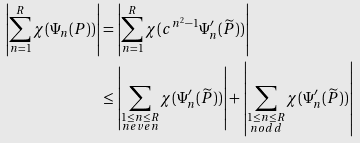<formula> <loc_0><loc_0><loc_500><loc_500>\left | \sum _ { n = 1 } ^ { R } \chi ( \Psi _ { n } ( P ) ) \right | & = \left | \sum _ { n = 1 } ^ { R } \chi ( c ^ { n ^ { 2 } - 1 } \Psi ^ { \prime } _ { n } ( \widetilde { P } ) ) \right | \\ & \leq \left | \sum _ { \substack { 1 \leq n \leq R \\ n e v e n } } \chi ( \Psi ^ { \prime } _ { n } ( \widetilde { P } ) ) \right | + \left | \sum _ { \substack { 1 \leq n \leq R \\ n o d d } } \chi ( \Psi ^ { \prime } _ { n } ( \widetilde { P } ) ) \right |</formula> 